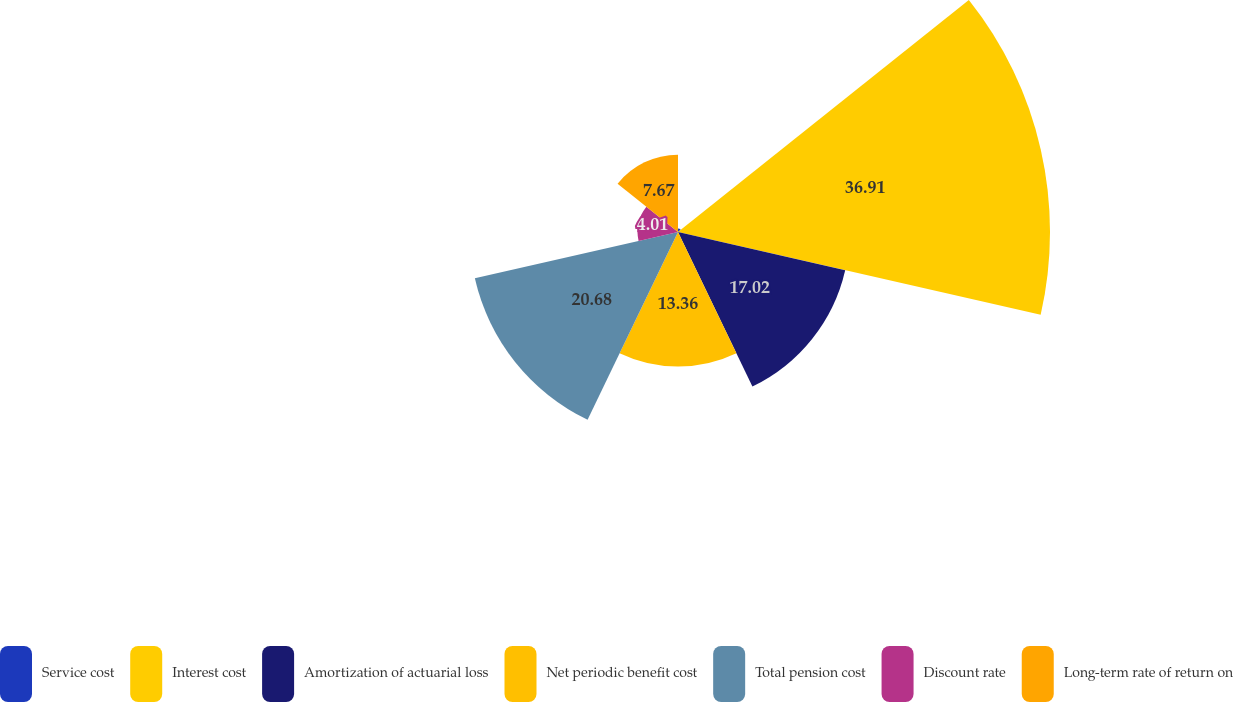Convert chart. <chart><loc_0><loc_0><loc_500><loc_500><pie_chart><fcel>Service cost<fcel>Interest cost<fcel>Amortization of actuarial loss<fcel>Net periodic benefit cost<fcel>Total pension cost<fcel>Discount rate<fcel>Long-term rate of return on<nl><fcel>0.35%<fcel>36.92%<fcel>17.02%<fcel>13.36%<fcel>20.68%<fcel>4.01%<fcel>7.67%<nl></chart> 